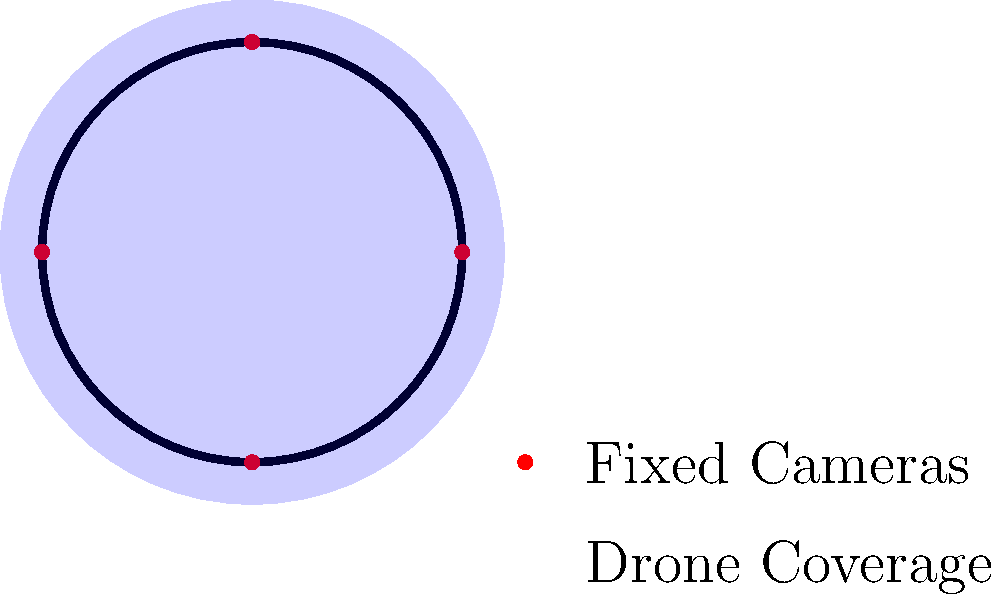Consider the circuit map above, which shows fixed camera positions (red dots) and the potential coverage area of a drone (blue shaded circle). If the drone's coverage radius is 1.2 times the width of the circuit, what percentage of the track length can the drone cover simultaneously compared to the combined coverage of all fixed cameras, assuming each fixed camera covers $\frac{1}{8}$ of the track length? To solve this problem, let's follow these steps:

1. Calculate the coverage of fixed cameras:
   - There are 4 fixed cameras
   - Each camera covers $\frac{1}{8}$ of the track length
   - Total fixed camera coverage = $4 \times \frac{1}{8} = \frac{1}{2}$ or 50% of the track

2. Estimate the drone's coverage:
   - The drone's coverage radius is 1.2 times the width of the circuit
   - This allows it to cover slightly more than half of the circuit's length
   - We can estimate the drone covers about 60% of the track length

3. Compare the coverage:
   - Fixed cameras: 50% of the track
   - Drone: approximately 60% of the track

4. Calculate the percentage difference:
   - Difference in coverage = Drone coverage - Fixed camera coverage
   - Difference = 60% - 50% = 10%

5. Express the difference as a percentage of fixed camera coverage:
   - Percentage increase = $\frac{\text{Difference}}{\text{Fixed camera coverage}} \times 100\%$
   - Percentage increase = $\frac{10\%}{50\%} \times 100\% = 20\%$

Therefore, the drone can cover approximately 20% more of the track length simultaneously compared to the combined coverage of all fixed cameras.
Answer: 20% more 